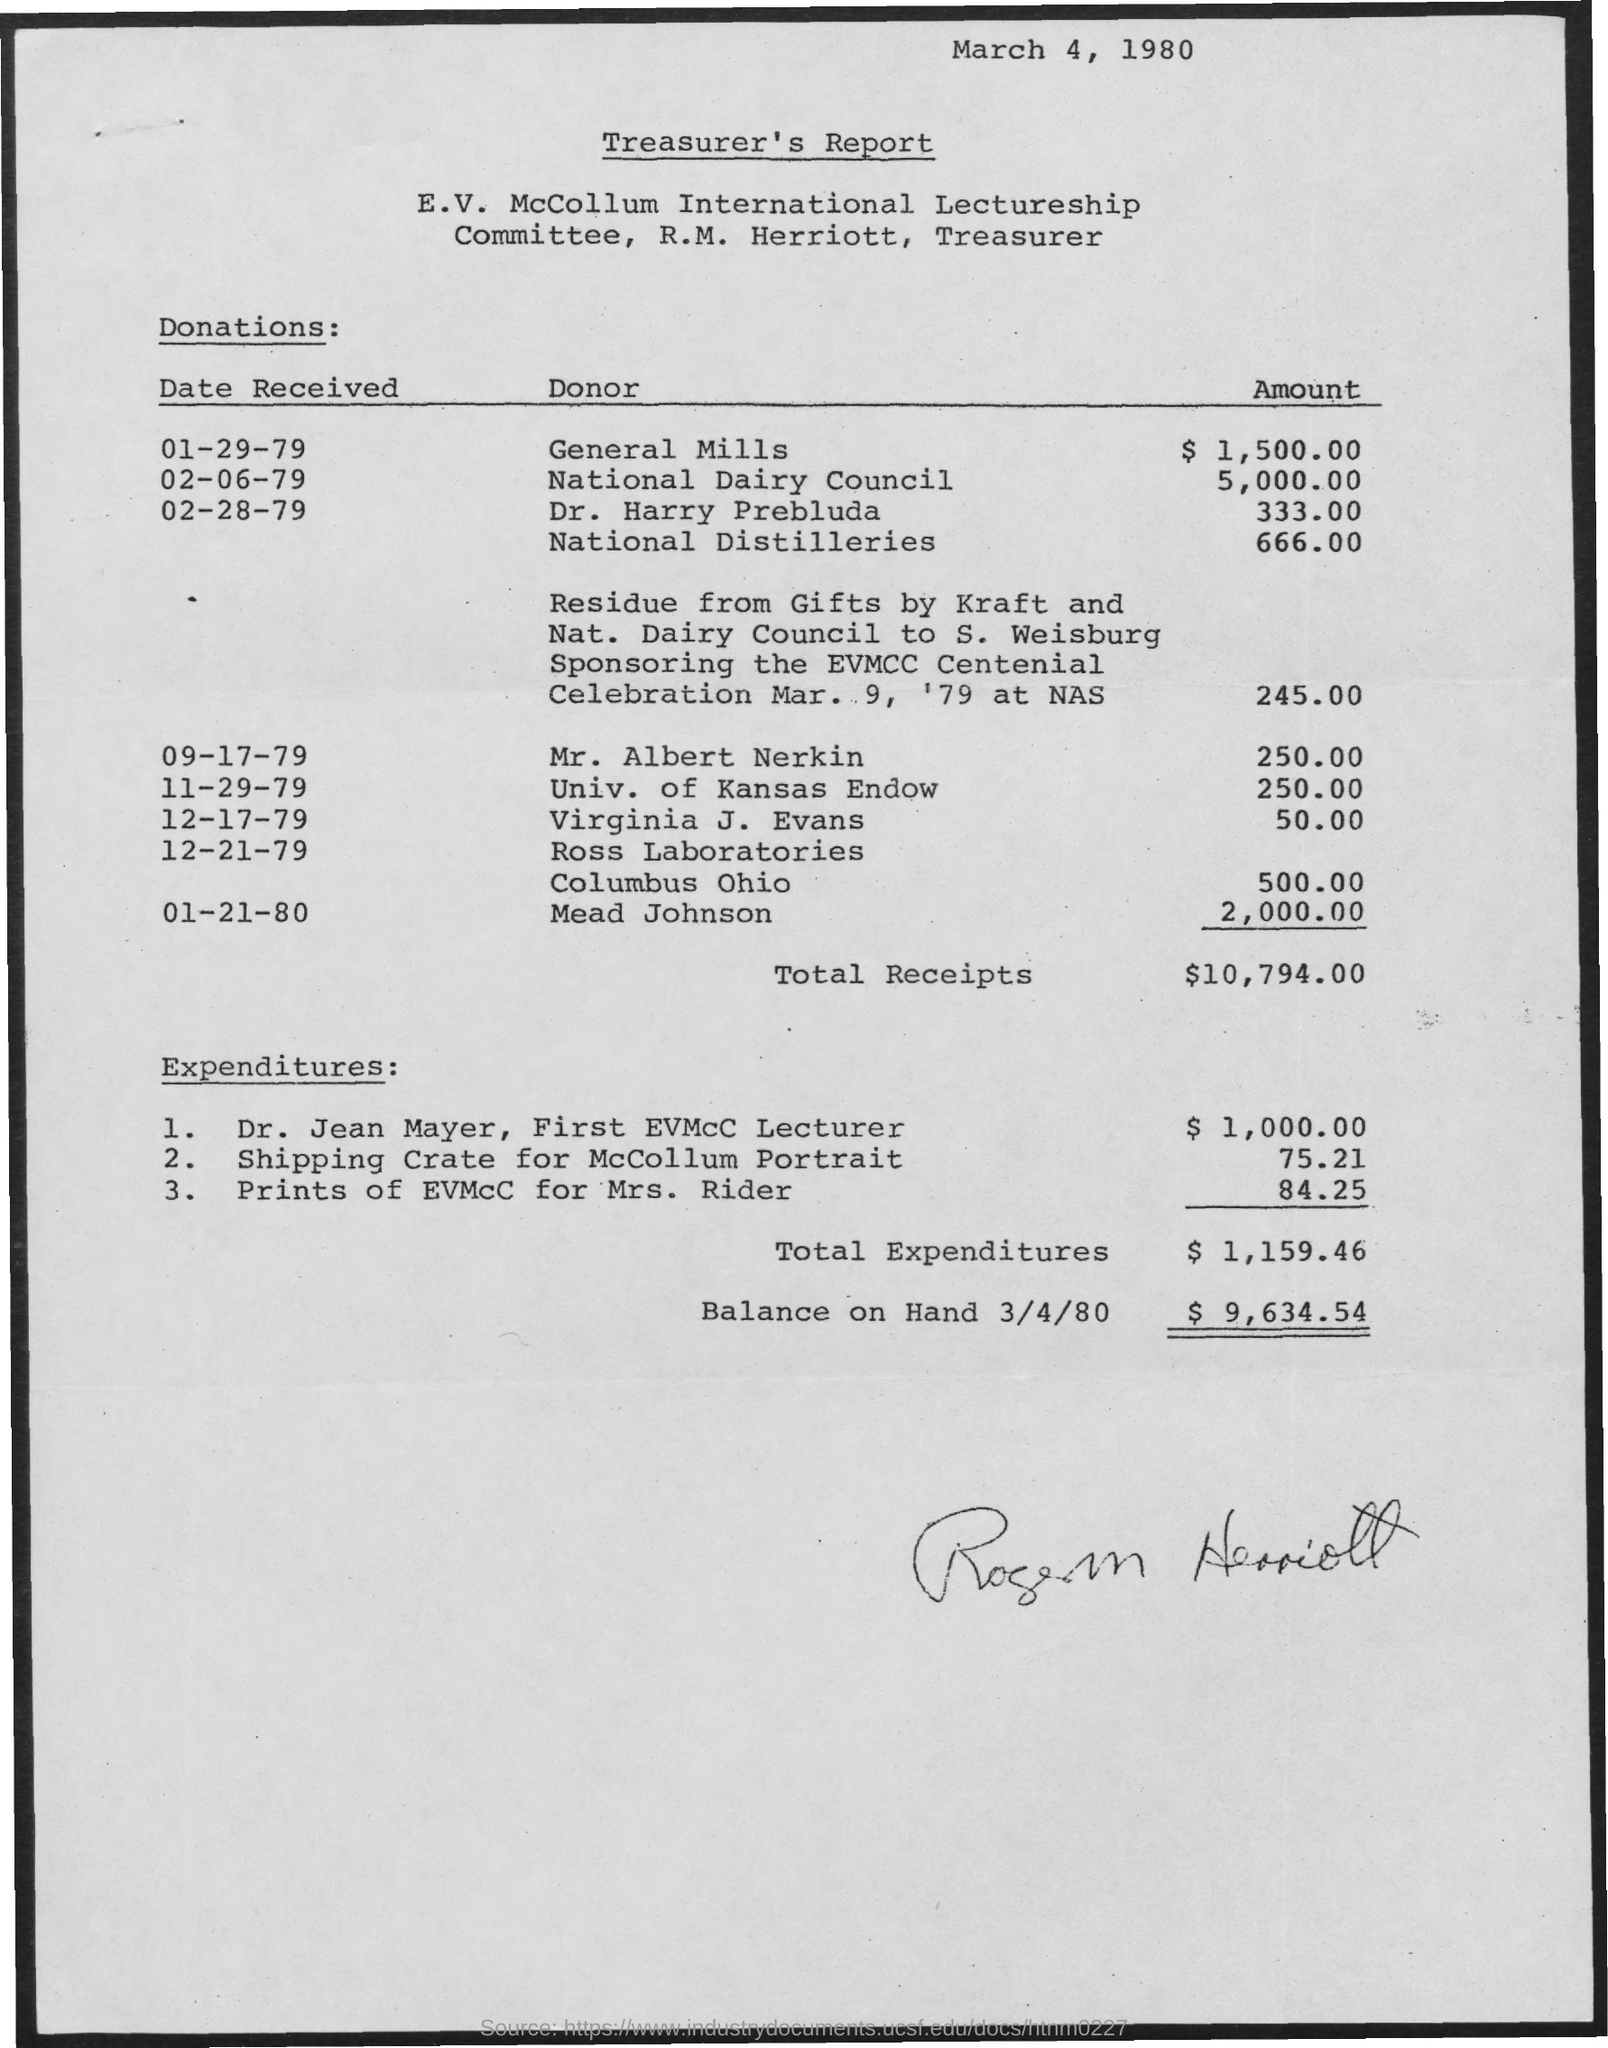Point out several critical features in this image. The National Dairy Council donated $5,000.00. The total receipts mentioned are $10,794.00. General Mills donated $1,500.00 to the cause mentioned. National Distilleries donated an amount of 666.00... The total expenditures mentioned are $1,159.46. 